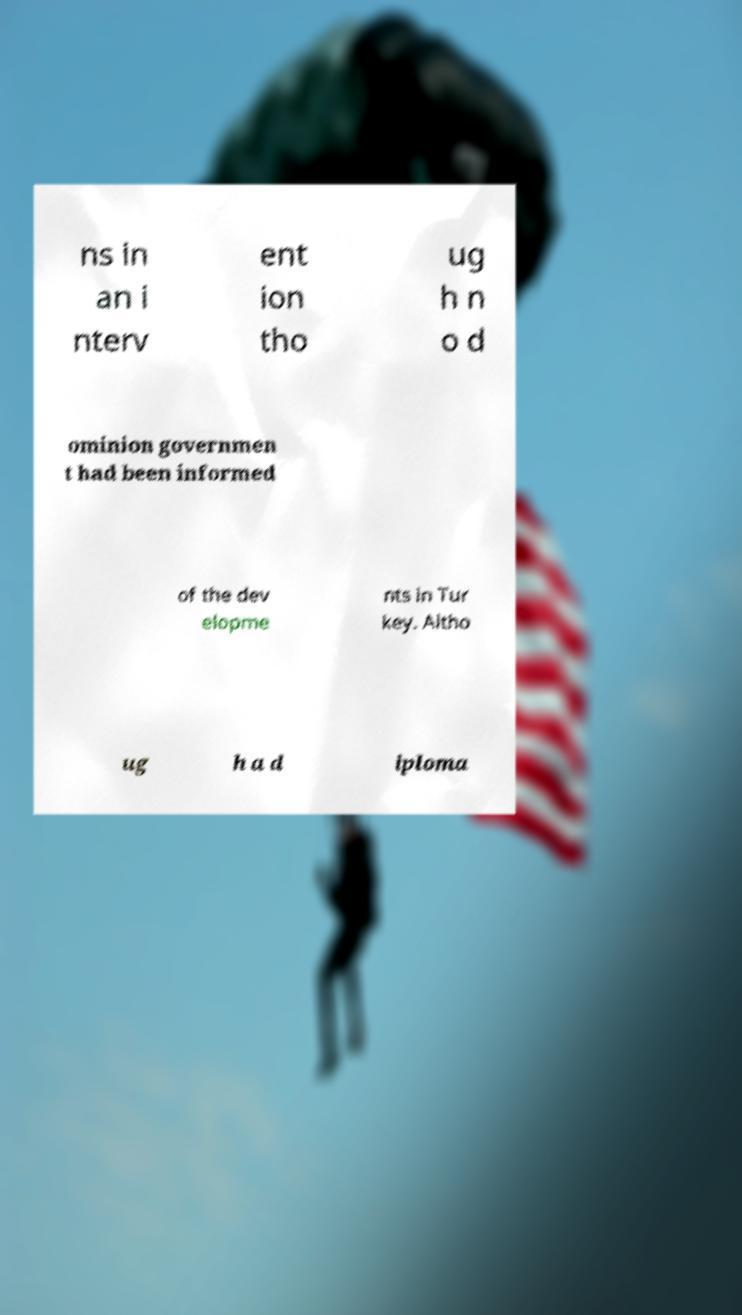Could you assist in decoding the text presented in this image and type it out clearly? ns in an i nterv ent ion tho ug h n o d ominion governmen t had been informed of the dev elopme nts in Tur key. Altho ug h a d iploma 